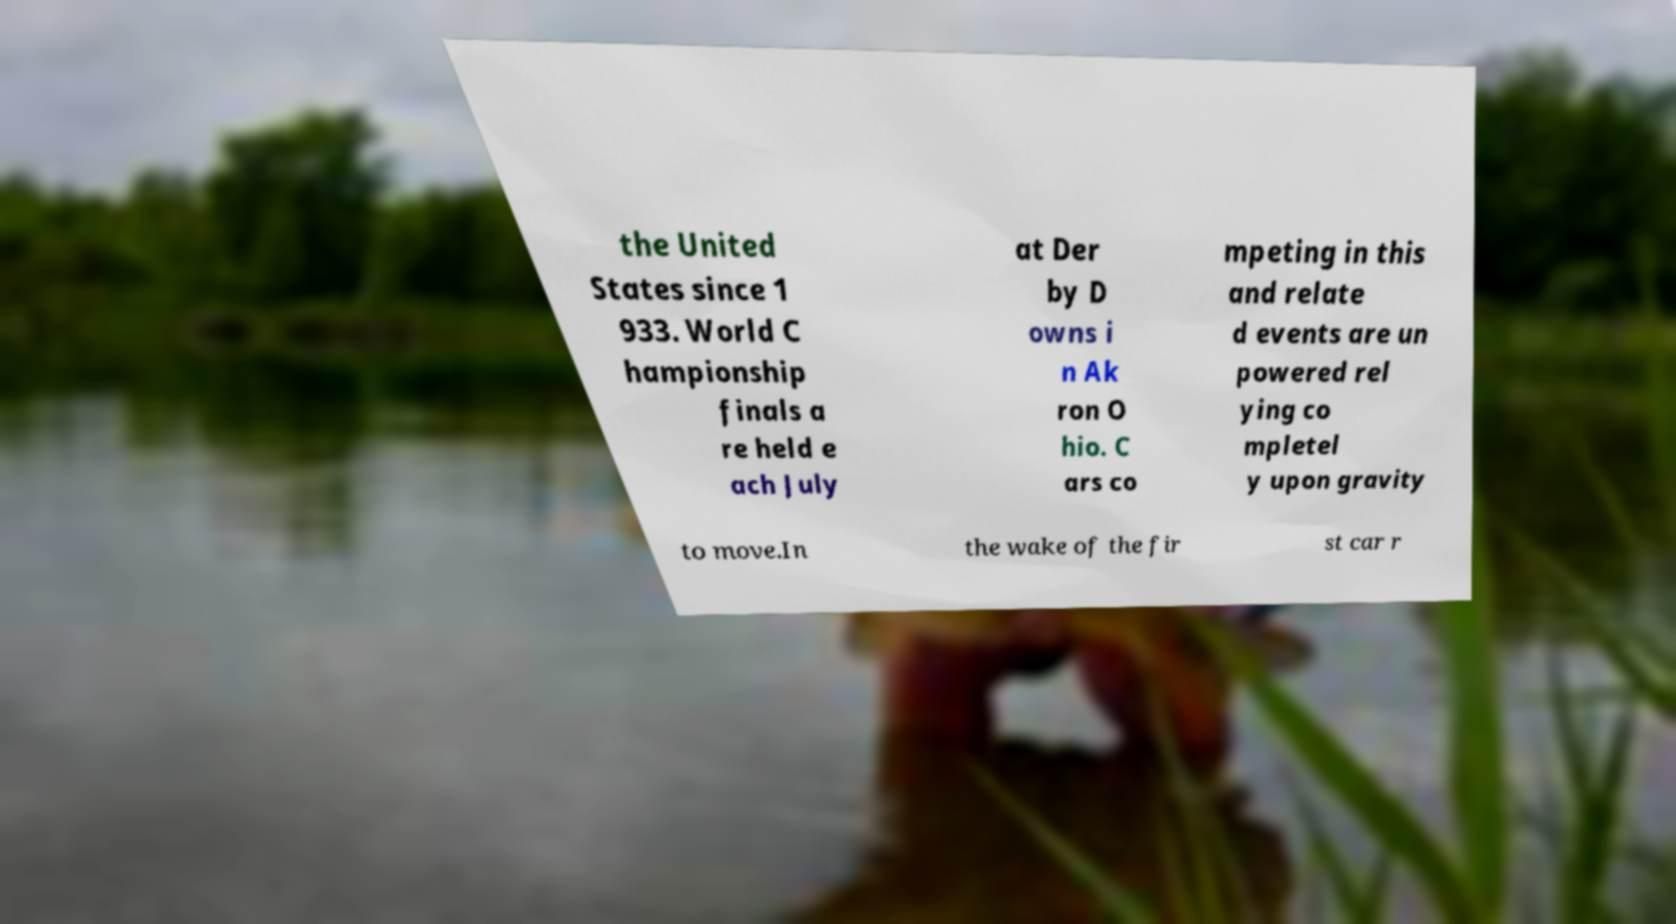Please read and relay the text visible in this image. What does it say? the United States since 1 933. World C hampionship finals a re held e ach July at Der by D owns i n Ak ron O hio. C ars co mpeting in this and relate d events are un powered rel ying co mpletel y upon gravity to move.In the wake of the fir st car r 